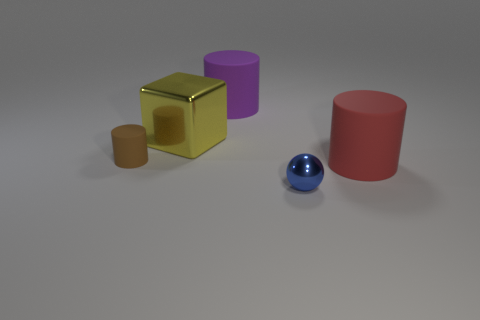The tiny thing that is to the right of the cube behind the thing to the left of the yellow shiny block is made of what material?
Give a very brief answer. Metal. The rubber thing to the left of the big yellow metal cube is what color?
Provide a short and direct response. Brown. Are there any other things that have the same shape as the tiny blue thing?
Provide a succinct answer. No. What size is the matte object that is in front of the cylinder on the left side of the big purple rubber object?
Keep it short and to the point. Large. Are there an equal number of yellow cubes in front of the blue metallic sphere and tiny matte cylinders left of the metallic block?
Offer a terse response. No. Are there any other things that have the same size as the block?
Your answer should be compact. Yes. There is a big thing that is the same material as the blue ball; what is its color?
Keep it short and to the point. Yellow. Does the big purple cylinder have the same material as the big cylinder that is in front of the big purple cylinder?
Provide a succinct answer. Yes. What is the color of the cylinder that is both in front of the big purple matte cylinder and left of the large red rubber cylinder?
Offer a very short reply. Brown. How many balls are small red matte things or large purple objects?
Make the answer very short. 0. 